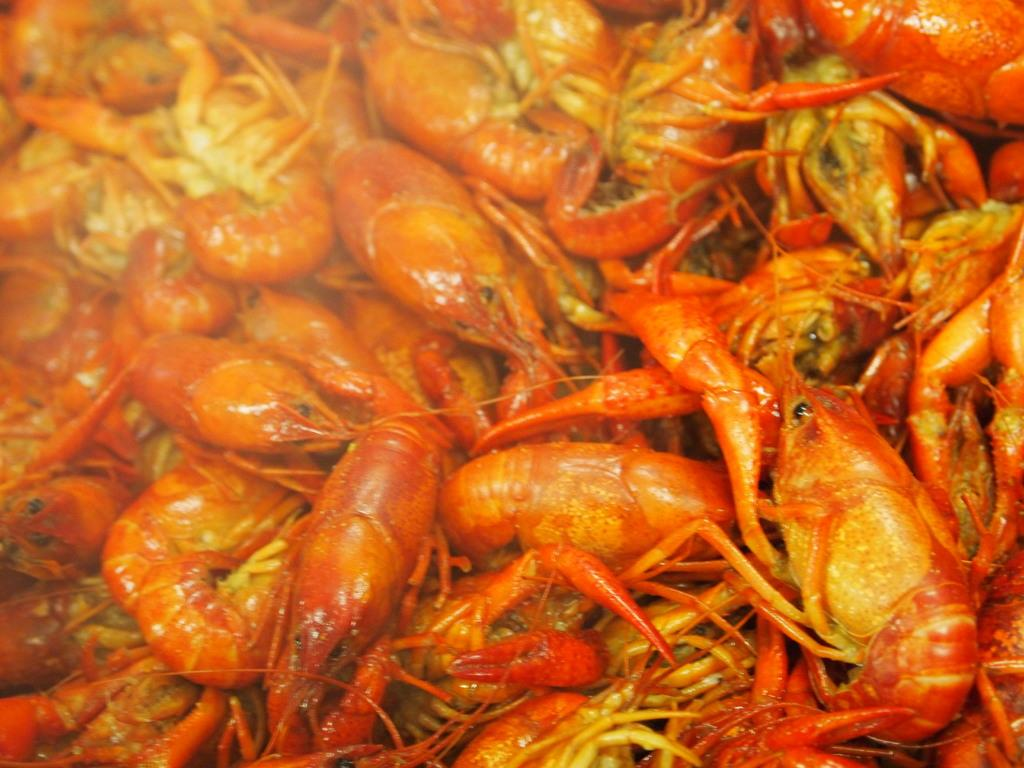What type of seafood is present in the image? There are prawns in the image. How are the prawns arranged or displayed in the image? The facts provided do not specify the arrangement or display of the prawns. Are the prawns cooked or raw in the image? The facts provided do not specify whether the prawns are cooked or raw. What type of feather can be seen in the image? There is no feather present in the image; it features prawns. 